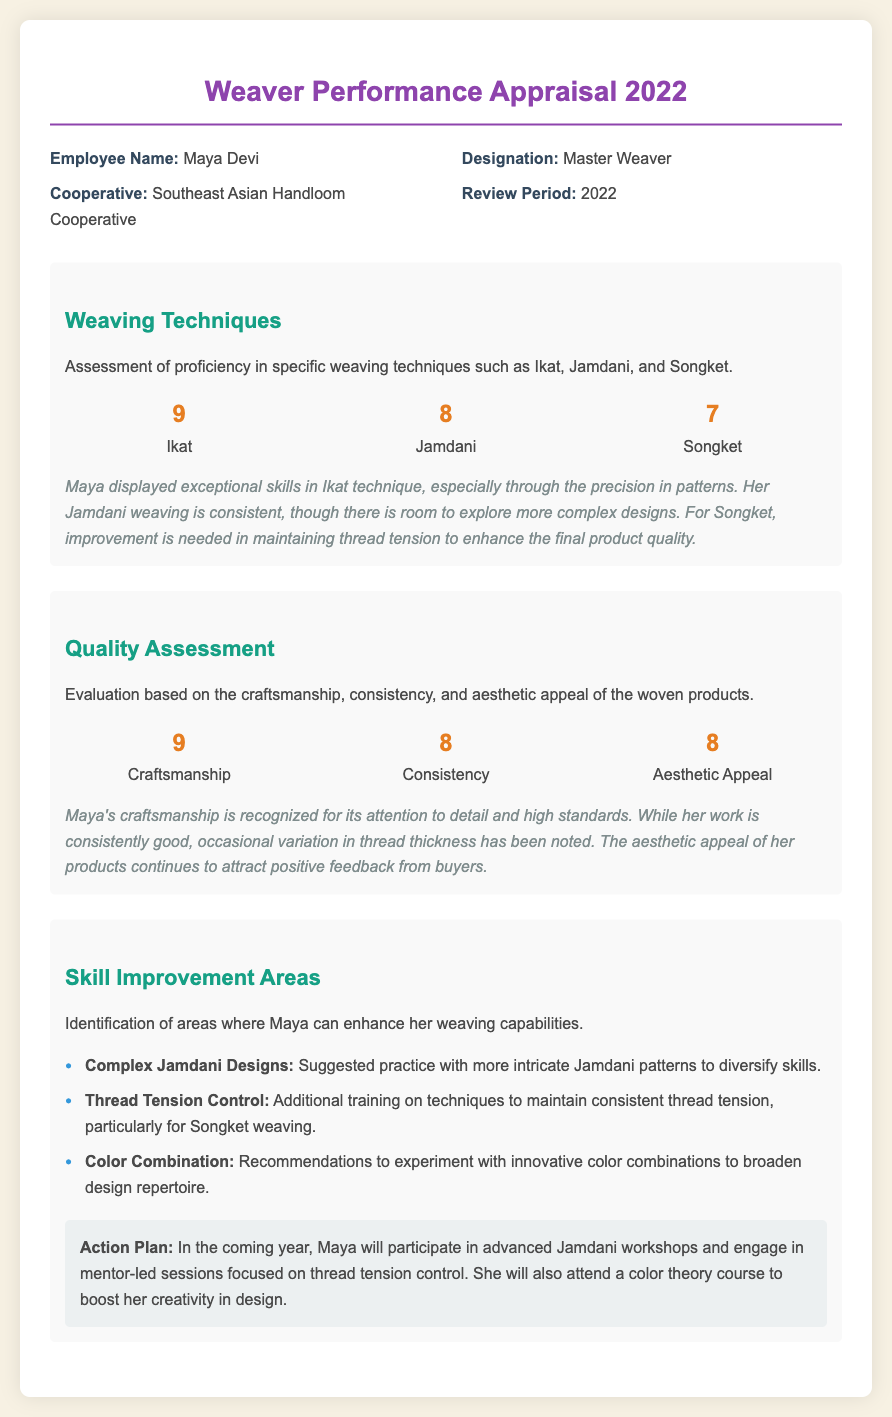what is the name of the employee? The name of the employee is listed under the "Employee Name" section of the document.
Answer: Maya Devi what is the employee's designation? The designation can be found in the top section of the document.
Answer: Master Weaver what cooperative does Maya belong to? The cooperative name is mentioned in the information section.
Answer: Southeast Asian Handloom Cooperative what is Maya's score in Ikat technique? The score for Ikat technique is clearly highlighted in the weaving techniques section.
Answer: 9 which weaving technique received the lowest score? To find this, we compare the scores in the weaving techniques section.
Answer: Songket how many improvement areas are identified for Maya? The number of improvement areas can be counted in the respective section of the document.
Answer: 3 what is the score given for craftsmanship? The craftsmanship score is specified in the Quality Assessment section.
Answer: 9 what is one of the suggested areas for skill improvement? The skill improvement areas are clearly listed, one of which is stated in the section.
Answer: Complex Jamdani Designs what action plan is proposed for Maya? The action plan for Maya is documented at the end of the Skill Improvement Areas section.
Answer: Participate in advanced Jamdani workshops what aesthetic appeal score did Maya receive? This score can be found in the scores presented in the Quality Assessment section.
Answer: 8 